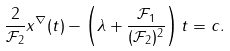<formula> <loc_0><loc_0><loc_500><loc_500>\frac { 2 } { \mathcal { F } _ { 2 } } x ^ { \nabla } ( t ) - \left ( \lambda + \frac { \mathcal { F } _ { 1 } } { ( \mathcal { F } _ { 2 } ) ^ { 2 } } \right ) t = c .</formula> 